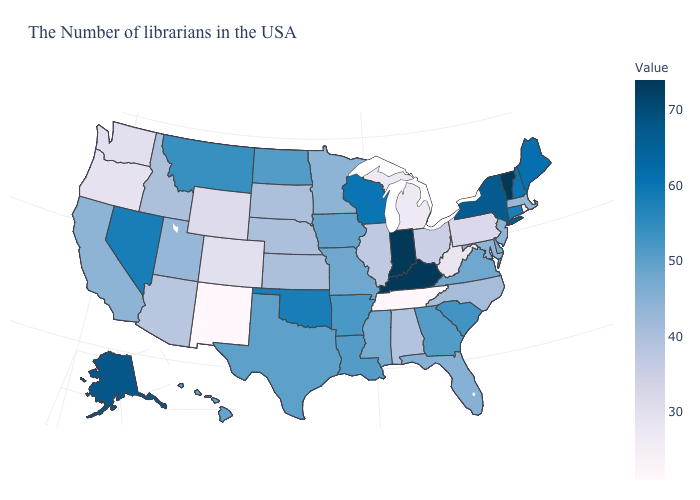Among the states that border Michigan , which have the highest value?
Be succinct. Indiana. Among the states that border South Dakota , does Wyoming have the lowest value?
Quick response, please. Yes. Does Montana have the lowest value in the West?
Short answer required. No. 